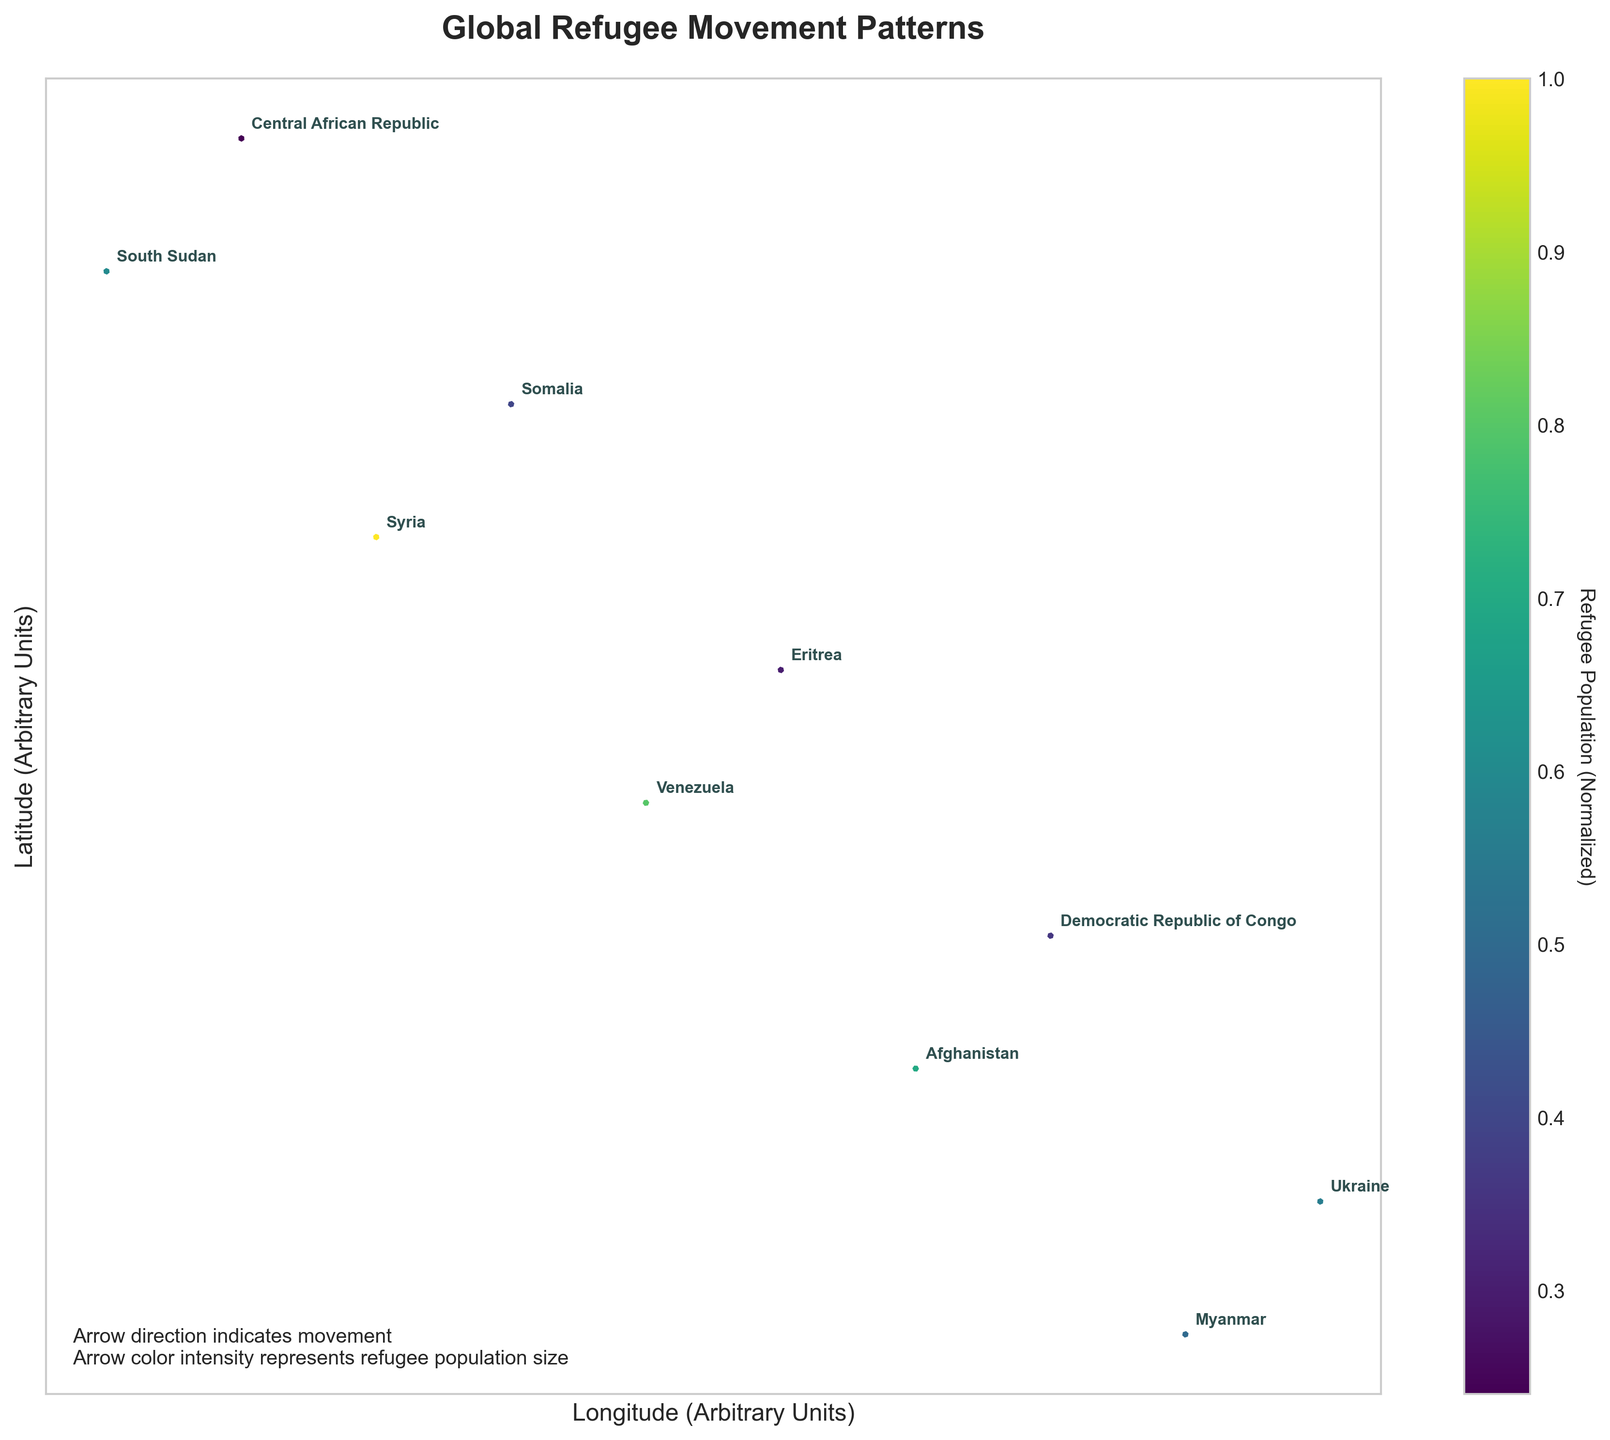What is the title of the figure? The title is typically located at the top of the plot. It is meant to summarize the main topic or data being visualized.
Answer: Global Refugee Movement Patterns Which country's arrow points upward, indicating a northward movement? Look for an arrow that has a significant upward (positive V direction) component.
Answer: Myanmar Which refugee population is represented by the largest arrow in the figure? The size of the arrows is proportional to the normalized refugee population. To find the largest, look for the thickest arrow.
Answer: Syria Which country has the smallest refugee population according to the color intensity of the arrows? The lighter the color of the arrow, the smaller the refugee population. Look for the lightest arrow.
Answer: Central African Republic What directions do most of the refugees from Ukraine move towards? Analyze the direction of Ukraine's arrow by examining its U (horizontal) and V (vertical) components. You can infer the movement directions from the arrow's orientation.
Answer: Southwest How do the refugee movements from Venezuela and Somalia compare in terms of direction? Compare the orientation of the arrows for Venezuela and Somalia by examining their U and V components.
Answer: Venezuela's refugees move southeast, while Somalia's move northwest Which two countries have refugee flows that both have a southward component? Identify the arrows with a significant negative V component (downward direction). Two such arrows are associated with two different countries.
Answer: Venezuela, Afghanistan What is the normalized refugee population for the country with coordinates (25, 75)? Locate the country at coordinates (25, 75) and find its normalized refugee population from the color bar.
Answer: 0.24 (Central African Republic) Which country located to the east of (40, 50) has the most intense refugee outflow? Eastern direction implies the arrows to the right of (40, 50). Compare the intensity of outflows based on arrow size and color.
Answer: Ukraine 